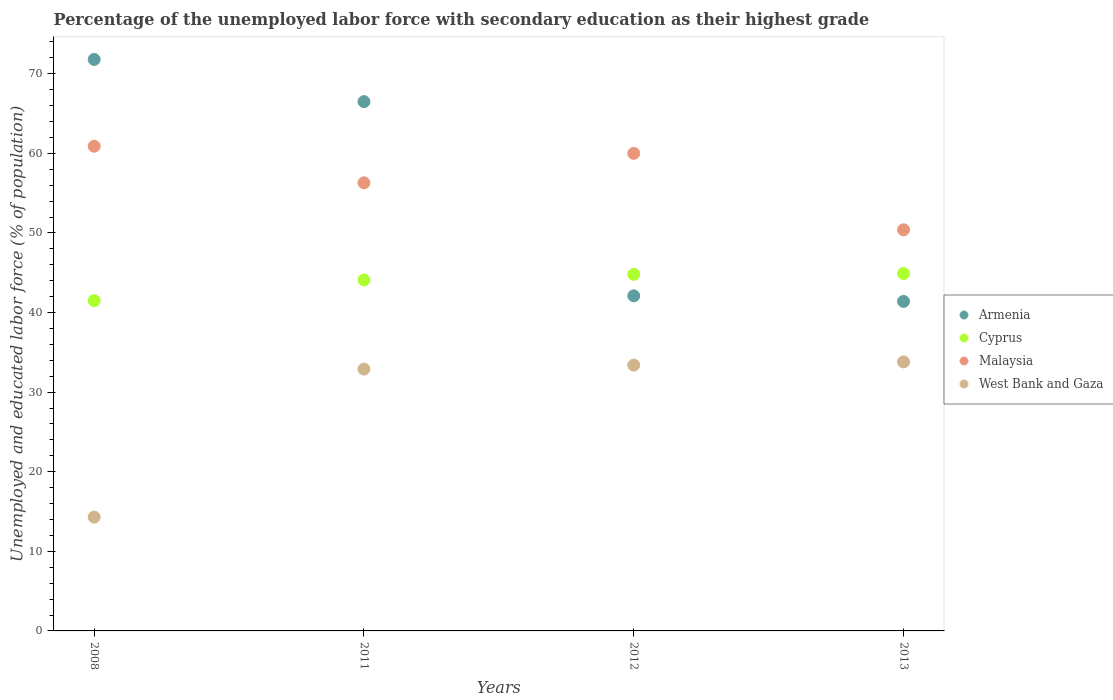Is the number of dotlines equal to the number of legend labels?
Offer a very short reply. Yes. What is the percentage of the unemployed labor force with secondary education in Armenia in 2013?
Provide a succinct answer. 41.4. Across all years, what is the maximum percentage of the unemployed labor force with secondary education in Cyprus?
Make the answer very short. 44.9. Across all years, what is the minimum percentage of the unemployed labor force with secondary education in Armenia?
Your answer should be very brief. 41.4. What is the total percentage of the unemployed labor force with secondary education in Armenia in the graph?
Offer a very short reply. 221.8. What is the difference between the percentage of the unemployed labor force with secondary education in Cyprus in 2012 and that in 2013?
Provide a succinct answer. -0.1. What is the difference between the percentage of the unemployed labor force with secondary education in Malaysia in 2011 and the percentage of the unemployed labor force with secondary education in Armenia in 2013?
Ensure brevity in your answer.  14.9. What is the average percentage of the unemployed labor force with secondary education in Cyprus per year?
Keep it short and to the point. 43.82. In the year 2012, what is the difference between the percentage of the unemployed labor force with secondary education in Malaysia and percentage of the unemployed labor force with secondary education in Cyprus?
Your answer should be very brief. 15.2. What is the ratio of the percentage of the unemployed labor force with secondary education in Cyprus in 2011 to that in 2012?
Make the answer very short. 0.98. Is the difference between the percentage of the unemployed labor force with secondary education in Malaysia in 2008 and 2013 greater than the difference between the percentage of the unemployed labor force with secondary education in Cyprus in 2008 and 2013?
Your response must be concise. Yes. What is the difference between the highest and the second highest percentage of the unemployed labor force with secondary education in West Bank and Gaza?
Keep it short and to the point. 0.4. In how many years, is the percentage of the unemployed labor force with secondary education in Malaysia greater than the average percentage of the unemployed labor force with secondary education in Malaysia taken over all years?
Offer a very short reply. 2. Is the sum of the percentage of the unemployed labor force with secondary education in Cyprus in 2008 and 2012 greater than the maximum percentage of the unemployed labor force with secondary education in West Bank and Gaza across all years?
Give a very brief answer. Yes. Is it the case that in every year, the sum of the percentage of the unemployed labor force with secondary education in West Bank and Gaza and percentage of the unemployed labor force with secondary education in Malaysia  is greater than the sum of percentage of the unemployed labor force with secondary education in Armenia and percentage of the unemployed labor force with secondary education in Cyprus?
Give a very brief answer. No. How many dotlines are there?
Provide a succinct answer. 4. How many years are there in the graph?
Offer a very short reply. 4. What is the difference between two consecutive major ticks on the Y-axis?
Your answer should be compact. 10. Are the values on the major ticks of Y-axis written in scientific E-notation?
Provide a short and direct response. No. Does the graph contain any zero values?
Offer a very short reply. No. Does the graph contain grids?
Keep it short and to the point. No. What is the title of the graph?
Offer a very short reply. Percentage of the unemployed labor force with secondary education as their highest grade. Does "Jordan" appear as one of the legend labels in the graph?
Your answer should be compact. No. What is the label or title of the X-axis?
Keep it short and to the point. Years. What is the label or title of the Y-axis?
Provide a succinct answer. Unemployed and educated labor force (% of population). What is the Unemployed and educated labor force (% of population) in Armenia in 2008?
Your answer should be very brief. 71.8. What is the Unemployed and educated labor force (% of population) in Cyprus in 2008?
Offer a terse response. 41.5. What is the Unemployed and educated labor force (% of population) of Malaysia in 2008?
Your answer should be compact. 60.9. What is the Unemployed and educated labor force (% of population) in West Bank and Gaza in 2008?
Your response must be concise. 14.3. What is the Unemployed and educated labor force (% of population) in Armenia in 2011?
Ensure brevity in your answer.  66.5. What is the Unemployed and educated labor force (% of population) of Cyprus in 2011?
Make the answer very short. 44.1. What is the Unemployed and educated labor force (% of population) of Malaysia in 2011?
Your answer should be very brief. 56.3. What is the Unemployed and educated labor force (% of population) in West Bank and Gaza in 2011?
Ensure brevity in your answer.  32.9. What is the Unemployed and educated labor force (% of population) of Armenia in 2012?
Offer a terse response. 42.1. What is the Unemployed and educated labor force (% of population) in Cyprus in 2012?
Your answer should be very brief. 44.8. What is the Unemployed and educated labor force (% of population) in Malaysia in 2012?
Your response must be concise. 60. What is the Unemployed and educated labor force (% of population) of West Bank and Gaza in 2012?
Your answer should be compact. 33.4. What is the Unemployed and educated labor force (% of population) in Armenia in 2013?
Your answer should be compact. 41.4. What is the Unemployed and educated labor force (% of population) in Cyprus in 2013?
Your answer should be very brief. 44.9. What is the Unemployed and educated labor force (% of population) in Malaysia in 2013?
Your response must be concise. 50.4. What is the Unemployed and educated labor force (% of population) in West Bank and Gaza in 2013?
Provide a short and direct response. 33.8. Across all years, what is the maximum Unemployed and educated labor force (% of population) in Armenia?
Your answer should be compact. 71.8. Across all years, what is the maximum Unemployed and educated labor force (% of population) in Cyprus?
Keep it short and to the point. 44.9. Across all years, what is the maximum Unemployed and educated labor force (% of population) of Malaysia?
Provide a short and direct response. 60.9. Across all years, what is the maximum Unemployed and educated labor force (% of population) in West Bank and Gaza?
Provide a succinct answer. 33.8. Across all years, what is the minimum Unemployed and educated labor force (% of population) in Armenia?
Ensure brevity in your answer.  41.4. Across all years, what is the minimum Unemployed and educated labor force (% of population) in Cyprus?
Keep it short and to the point. 41.5. Across all years, what is the minimum Unemployed and educated labor force (% of population) in Malaysia?
Offer a terse response. 50.4. Across all years, what is the minimum Unemployed and educated labor force (% of population) of West Bank and Gaza?
Keep it short and to the point. 14.3. What is the total Unemployed and educated labor force (% of population) in Armenia in the graph?
Give a very brief answer. 221.8. What is the total Unemployed and educated labor force (% of population) of Cyprus in the graph?
Provide a short and direct response. 175.3. What is the total Unemployed and educated labor force (% of population) of Malaysia in the graph?
Keep it short and to the point. 227.6. What is the total Unemployed and educated labor force (% of population) in West Bank and Gaza in the graph?
Provide a succinct answer. 114.4. What is the difference between the Unemployed and educated labor force (% of population) of Armenia in 2008 and that in 2011?
Your answer should be compact. 5.3. What is the difference between the Unemployed and educated labor force (% of population) of Cyprus in 2008 and that in 2011?
Provide a succinct answer. -2.6. What is the difference between the Unemployed and educated labor force (% of population) in Malaysia in 2008 and that in 2011?
Offer a very short reply. 4.6. What is the difference between the Unemployed and educated labor force (% of population) of West Bank and Gaza in 2008 and that in 2011?
Offer a terse response. -18.6. What is the difference between the Unemployed and educated labor force (% of population) of Armenia in 2008 and that in 2012?
Your response must be concise. 29.7. What is the difference between the Unemployed and educated labor force (% of population) of Cyprus in 2008 and that in 2012?
Your answer should be compact. -3.3. What is the difference between the Unemployed and educated labor force (% of population) of Malaysia in 2008 and that in 2012?
Make the answer very short. 0.9. What is the difference between the Unemployed and educated labor force (% of population) in West Bank and Gaza in 2008 and that in 2012?
Offer a very short reply. -19.1. What is the difference between the Unemployed and educated labor force (% of population) of Armenia in 2008 and that in 2013?
Your response must be concise. 30.4. What is the difference between the Unemployed and educated labor force (% of population) of Cyprus in 2008 and that in 2013?
Your response must be concise. -3.4. What is the difference between the Unemployed and educated labor force (% of population) of West Bank and Gaza in 2008 and that in 2013?
Keep it short and to the point. -19.5. What is the difference between the Unemployed and educated labor force (% of population) in Armenia in 2011 and that in 2012?
Offer a very short reply. 24.4. What is the difference between the Unemployed and educated labor force (% of population) in West Bank and Gaza in 2011 and that in 2012?
Provide a succinct answer. -0.5. What is the difference between the Unemployed and educated labor force (% of population) of Armenia in 2011 and that in 2013?
Give a very brief answer. 25.1. What is the difference between the Unemployed and educated labor force (% of population) of Cyprus in 2011 and that in 2013?
Keep it short and to the point. -0.8. What is the difference between the Unemployed and educated labor force (% of population) of Armenia in 2008 and the Unemployed and educated labor force (% of population) of Cyprus in 2011?
Your answer should be very brief. 27.7. What is the difference between the Unemployed and educated labor force (% of population) of Armenia in 2008 and the Unemployed and educated labor force (% of population) of Malaysia in 2011?
Ensure brevity in your answer.  15.5. What is the difference between the Unemployed and educated labor force (% of population) of Armenia in 2008 and the Unemployed and educated labor force (% of population) of West Bank and Gaza in 2011?
Keep it short and to the point. 38.9. What is the difference between the Unemployed and educated labor force (% of population) of Cyprus in 2008 and the Unemployed and educated labor force (% of population) of Malaysia in 2011?
Offer a terse response. -14.8. What is the difference between the Unemployed and educated labor force (% of population) of Malaysia in 2008 and the Unemployed and educated labor force (% of population) of West Bank and Gaza in 2011?
Provide a short and direct response. 28. What is the difference between the Unemployed and educated labor force (% of population) of Armenia in 2008 and the Unemployed and educated labor force (% of population) of West Bank and Gaza in 2012?
Give a very brief answer. 38.4. What is the difference between the Unemployed and educated labor force (% of population) of Cyprus in 2008 and the Unemployed and educated labor force (% of population) of Malaysia in 2012?
Keep it short and to the point. -18.5. What is the difference between the Unemployed and educated labor force (% of population) of Cyprus in 2008 and the Unemployed and educated labor force (% of population) of West Bank and Gaza in 2012?
Your answer should be compact. 8.1. What is the difference between the Unemployed and educated labor force (% of population) in Malaysia in 2008 and the Unemployed and educated labor force (% of population) in West Bank and Gaza in 2012?
Make the answer very short. 27.5. What is the difference between the Unemployed and educated labor force (% of population) in Armenia in 2008 and the Unemployed and educated labor force (% of population) in Cyprus in 2013?
Ensure brevity in your answer.  26.9. What is the difference between the Unemployed and educated labor force (% of population) in Armenia in 2008 and the Unemployed and educated labor force (% of population) in Malaysia in 2013?
Ensure brevity in your answer.  21.4. What is the difference between the Unemployed and educated labor force (% of population) in Armenia in 2008 and the Unemployed and educated labor force (% of population) in West Bank and Gaza in 2013?
Keep it short and to the point. 38. What is the difference between the Unemployed and educated labor force (% of population) of Cyprus in 2008 and the Unemployed and educated labor force (% of population) of Malaysia in 2013?
Offer a very short reply. -8.9. What is the difference between the Unemployed and educated labor force (% of population) of Malaysia in 2008 and the Unemployed and educated labor force (% of population) of West Bank and Gaza in 2013?
Your answer should be compact. 27.1. What is the difference between the Unemployed and educated labor force (% of population) of Armenia in 2011 and the Unemployed and educated labor force (% of population) of Cyprus in 2012?
Give a very brief answer. 21.7. What is the difference between the Unemployed and educated labor force (% of population) of Armenia in 2011 and the Unemployed and educated labor force (% of population) of West Bank and Gaza in 2012?
Offer a very short reply. 33.1. What is the difference between the Unemployed and educated labor force (% of population) of Cyprus in 2011 and the Unemployed and educated labor force (% of population) of Malaysia in 2012?
Your answer should be very brief. -15.9. What is the difference between the Unemployed and educated labor force (% of population) in Cyprus in 2011 and the Unemployed and educated labor force (% of population) in West Bank and Gaza in 2012?
Give a very brief answer. 10.7. What is the difference between the Unemployed and educated labor force (% of population) in Malaysia in 2011 and the Unemployed and educated labor force (% of population) in West Bank and Gaza in 2012?
Give a very brief answer. 22.9. What is the difference between the Unemployed and educated labor force (% of population) in Armenia in 2011 and the Unemployed and educated labor force (% of population) in Cyprus in 2013?
Provide a succinct answer. 21.6. What is the difference between the Unemployed and educated labor force (% of population) in Armenia in 2011 and the Unemployed and educated labor force (% of population) in Malaysia in 2013?
Offer a terse response. 16.1. What is the difference between the Unemployed and educated labor force (% of population) of Armenia in 2011 and the Unemployed and educated labor force (% of population) of West Bank and Gaza in 2013?
Give a very brief answer. 32.7. What is the difference between the Unemployed and educated labor force (% of population) of Cyprus in 2011 and the Unemployed and educated labor force (% of population) of Malaysia in 2013?
Keep it short and to the point. -6.3. What is the difference between the Unemployed and educated labor force (% of population) of Cyprus in 2011 and the Unemployed and educated labor force (% of population) of West Bank and Gaza in 2013?
Give a very brief answer. 10.3. What is the difference between the Unemployed and educated labor force (% of population) in Armenia in 2012 and the Unemployed and educated labor force (% of population) in Cyprus in 2013?
Provide a short and direct response. -2.8. What is the difference between the Unemployed and educated labor force (% of population) of Armenia in 2012 and the Unemployed and educated labor force (% of population) of Malaysia in 2013?
Keep it short and to the point. -8.3. What is the difference between the Unemployed and educated labor force (% of population) of Armenia in 2012 and the Unemployed and educated labor force (% of population) of West Bank and Gaza in 2013?
Your response must be concise. 8.3. What is the difference between the Unemployed and educated labor force (% of population) of Cyprus in 2012 and the Unemployed and educated labor force (% of population) of Malaysia in 2013?
Give a very brief answer. -5.6. What is the difference between the Unemployed and educated labor force (% of population) of Cyprus in 2012 and the Unemployed and educated labor force (% of population) of West Bank and Gaza in 2013?
Give a very brief answer. 11. What is the difference between the Unemployed and educated labor force (% of population) of Malaysia in 2012 and the Unemployed and educated labor force (% of population) of West Bank and Gaza in 2013?
Make the answer very short. 26.2. What is the average Unemployed and educated labor force (% of population) in Armenia per year?
Give a very brief answer. 55.45. What is the average Unemployed and educated labor force (% of population) of Cyprus per year?
Give a very brief answer. 43.83. What is the average Unemployed and educated labor force (% of population) of Malaysia per year?
Offer a terse response. 56.9. What is the average Unemployed and educated labor force (% of population) of West Bank and Gaza per year?
Provide a short and direct response. 28.6. In the year 2008, what is the difference between the Unemployed and educated labor force (% of population) of Armenia and Unemployed and educated labor force (% of population) of Cyprus?
Your answer should be very brief. 30.3. In the year 2008, what is the difference between the Unemployed and educated labor force (% of population) of Armenia and Unemployed and educated labor force (% of population) of Malaysia?
Make the answer very short. 10.9. In the year 2008, what is the difference between the Unemployed and educated labor force (% of population) of Armenia and Unemployed and educated labor force (% of population) of West Bank and Gaza?
Ensure brevity in your answer.  57.5. In the year 2008, what is the difference between the Unemployed and educated labor force (% of population) in Cyprus and Unemployed and educated labor force (% of population) in Malaysia?
Your answer should be very brief. -19.4. In the year 2008, what is the difference between the Unemployed and educated labor force (% of population) of Cyprus and Unemployed and educated labor force (% of population) of West Bank and Gaza?
Provide a succinct answer. 27.2. In the year 2008, what is the difference between the Unemployed and educated labor force (% of population) in Malaysia and Unemployed and educated labor force (% of population) in West Bank and Gaza?
Make the answer very short. 46.6. In the year 2011, what is the difference between the Unemployed and educated labor force (% of population) in Armenia and Unemployed and educated labor force (% of population) in Cyprus?
Provide a short and direct response. 22.4. In the year 2011, what is the difference between the Unemployed and educated labor force (% of population) in Armenia and Unemployed and educated labor force (% of population) in West Bank and Gaza?
Offer a very short reply. 33.6. In the year 2011, what is the difference between the Unemployed and educated labor force (% of population) of Malaysia and Unemployed and educated labor force (% of population) of West Bank and Gaza?
Ensure brevity in your answer.  23.4. In the year 2012, what is the difference between the Unemployed and educated labor force (% of population) of Armenia and Unemployed and educated labor force (% of population) of Cyprus?
Provide a succinct answer. -2.7. In the year 2012, what is the difference between the Unemployed and educated labor force (% of population) of Armenia and Unemployed and educated labor force (% of population) of Malaysia?
Ensure brevity in your answer.  -17.9. In the year 2012, what is the difference between the Unemployed and educated labor force (% of population) in Armenia and Unemployed and educated labor force (% of population) in West Bank and Gaza?
Keep it short and to the point. 8.7. In the year 2012, what is the difference between the Unemployed and educated labor force (% of population) in Cyprus and Unemployed and educated labor force (% of population) in Malaysia?
Give a very brief answer. -15.2. In the year 2012, what is the difference between the Unemployed and educated labor force (% of population) in Malaysia and Unemployed and educated labor force (% of population) in West Bank and Gaza?
Provide a succinct answer. 26.6. In the year 2013, what is the difference between the Unemployed and educated labor force (% of population) in Armenia and Unemployed and educated labor force (% of population) in Malaysia?
Your answer should be compact. -9. In the year 2013, what is the difference between the Unemployed and educated labor force (% of population) of Cyprus and Unemployed and educated labor force (% of population) of Malaysia?
Provide a succinct answer. -5.5. In the year 2013, what is the difference between the Unemployed and educated labor force (% of population) in Cyprus and Unemployed and educated labor force (% of population) in West Bank and Gaza?
Provide a succinct answer. 11.1. What is the ratio of the Unemployed and educated labor force (% of population) of Armenia in 2008 to that in 2011?
Provide a succinct answer. 1.08. What is the ratio of the Unemployed and educated labor force (% of population) of Cyprus in 2008 to that in 2011?
Make the answer very short. 0.94. What is the ratio of the Unemployed and educated labor force (% of population) in Malaysia in 2008 to that in 2011?
Offer a very short reply. 1.08. What is the ratio of the Unemployed and educated labor force (% of population) of West Bank and Gaza in 2008 to that in 2011?
Keep it short and to the point. 0.43. What is the ratio of the Unemployed and educated labor force (% of population) of Armenia in 2008 to that in 2012?
Your response must be concise. 1.71. What is the ratio of the Unemployed and educated labor force (% of population) of Cyprus in 2008 to that in 2012?
Your response must be concise. 0.93. What is the ratio of the Unemployed and educated labor force (% of population) in Malaysia in 2008 to that in 2012?
Give a very brief answer. 1.01. What is the ratio of the Unemployed and educated labor force (% of population) in West Bank and Gaza in 2008 to that in 2012?
Offer a very short reply. 0.43. What is the ratio of the Unemployed and educated labor force (% of population) in Armenia in 2008 to that in 2013?
Your answer should be very brief. 1.73. What is the ratio of the Unemployed and educated labor force (% of population) in Cyprus in 2008 to that in 2013?
Your answer should be very brief. 0.92. What is the ratio of the Unemployed and educated labor force (% of population) in Malaysia in 2008 to that in 2013?
Give a very brief answer. 1.21. What is the ratio of the Unemployed and educated labor force (% of population) in West Bank and Gaza in 2008 to that in 2013?
Offer a terse response. 0.42. What is the ratio of the Unemployed and educated labor force (% of population) in Armenia in 2011 to that in 2012?
Provide a short and direct response. 1.58. What is the ratio of the Unemployed and educated labor force (% of population) in Cyprus in 2011 to that in 2012?
Keep it short and to the point. 0.98. What is the ratio of the Unemployed and educated labor force (% of population) in Malaysia in 2011 to that in 2012?
Give a very brief answer. 0.94. What is the ratio of the Unemployed and educated labor force (% of population) of West Bank and Gaza in 2011 to that in 2012?
Provide a short and direct response. 0.98. What is the ratio of the Unemployed and educated labor force (% of population) of Armenia in 2011 to that in 2013?
Provide a short and direct response. 1.61. What is the ratio of the Unemployed and educated labor force (% of population) of Cyprus in 2011 to that in 2013?
Ensure brevity in your answer.  0.98. What is the ratio of the Unemployed and educated labor force (% of population) of Malaysia in 2011 to that in 2013?
Offer a terse response. 1.12. What is the ratio of the Unemployed and educated labor force (% of population) in West Bank and Gaza in 2011 to that in 2013?
Offer a terse response. 0.97. What is the ratio of the Unemployed and educated labor force (% of population) in Armenia in 2012 to that in 2013?
Give a very brief answer. 1.02. What is the ratio of the Unemployed and educated labor force (% of population) in Malaysia in 2012 to that in 2013?
Your answer should be very brief. 1.19. What is the difference between the highest and the second highest Unemployed and educated labor force (% of population) in Armenia?
Make the answer very short. 5.3. What is the difference between the highest and the second highest Unemployed and educated labor force (% of population) in Cyprus?
Offer a very short reply. 0.1. What is the difference between the highest and the second highest Unemployed and educated labor force (% of population) of West Bank and Gaza?
Ensure brevity in your answer.  0.4. What is the difference between the highest and the lowest Unemployed and educated labor force (% of population) in Armenia?
Your response must be concise. 30.4. 